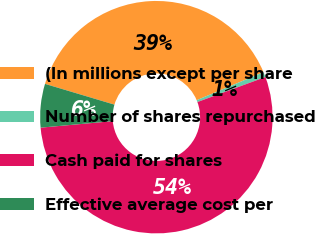Convert chart. <chart><loc_0><loc_0><loc_500><loc_500><pie_chart><fcel>(In millions except per share<fcel>Number of shares repurchased<fcel>Cash paid for shares<fcel>Effective average cost per<nl><fcel>39.04%<fcel>0.72%<fcel>54.17%<fcel>6.06%<nl></chart> 